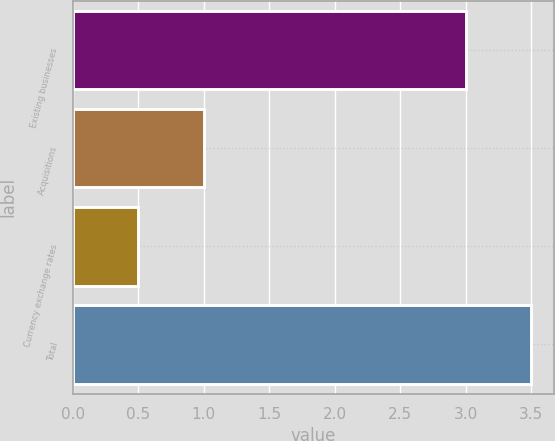Convert chart. <chart><loc_0><loc_0><loc_500><loc_500><bar_chart><fcel>Existing businesses<fcel>Acquisitions<fcel>Currency exchange rates<fcel>Total<nl><fcel>3<fcel>1<fcel>0.5<fcel>3.5<nl></chart> 